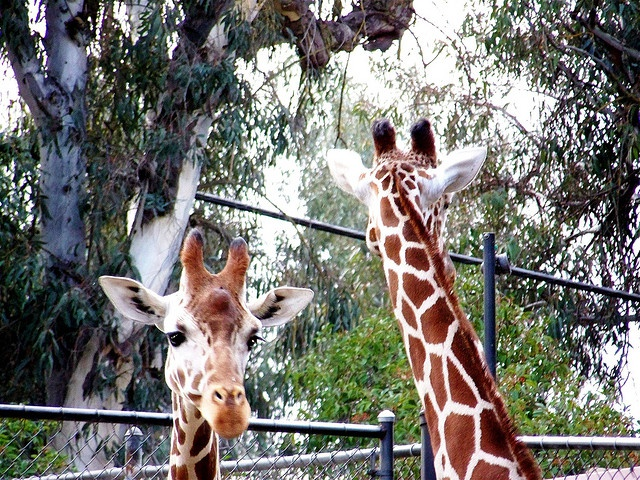Describe the objects in this image and their specific colors. I can see giraffe in black, white, maroon, and brown tones and giraffe in black, white, brown, tan, and darkgray tones in this image. 